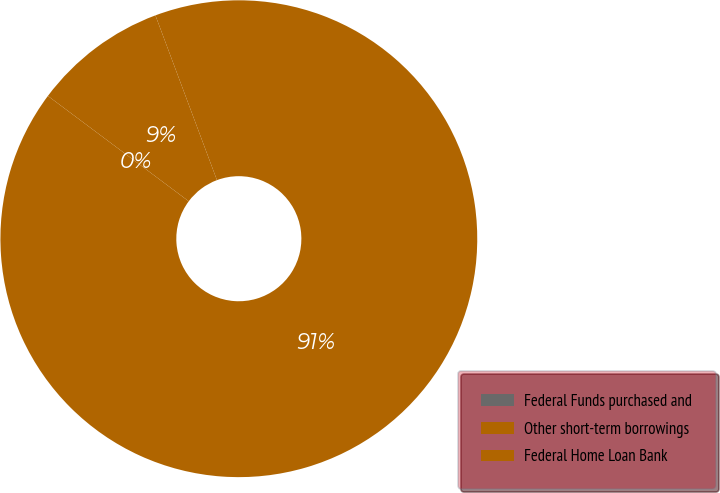<chart> <loc_0><loc_0><loc_500><loc_500><pie_chart><fcel>Federal Funds purchased and<fcel>Other short-term borrowings<fcel>Federal Home Loan Bank<nl><fcel>0.0%<fcel>9.09%<fcel>90.9%<nl></chart> 